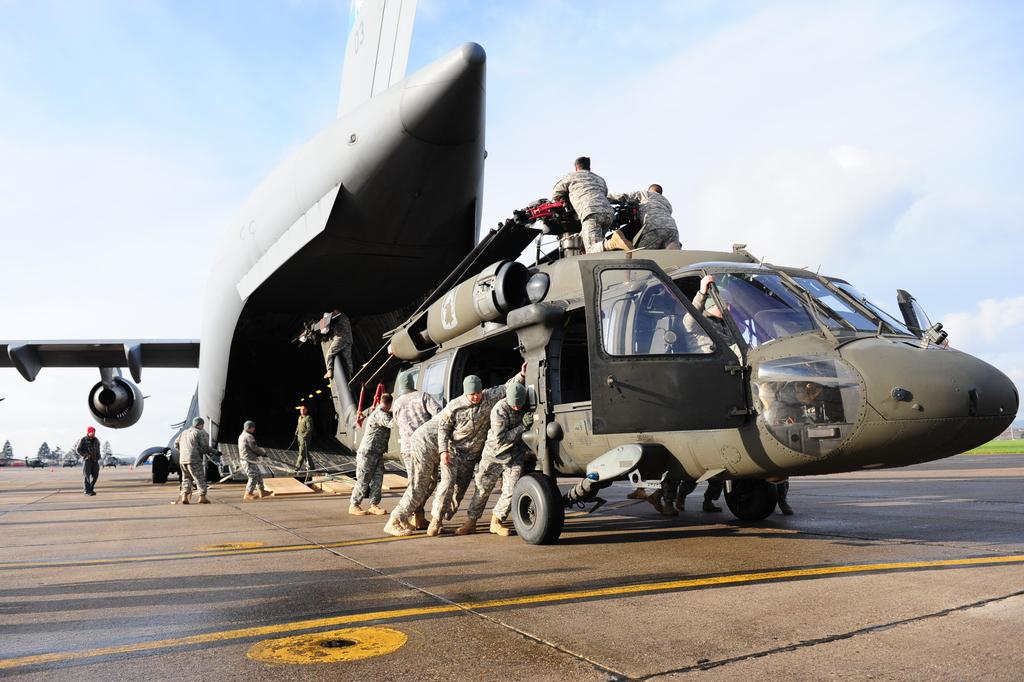What type of vehicle is present in the image? There is an army hercules in the image. What other mode of transportation can be seen in the image? There is a chopper in the image. Who is present on the runway in the image? There are people on the runway in the image. What is located behind the army hercules? There are vehicles behind the army hercules. What can be seen in the sky in the image? The sky is visible in the image. Can you tell me how many scarecrows are standing near the army hercules in the image? There are no scarecrows present in the image; it features an army hercules, a chopper, people on the runway, vehicles, and a visible sky. What type of muscle does the expert have in the image? There is no expert or reference to muscles in the image; it focuses on vehicles, people, and the sky. 